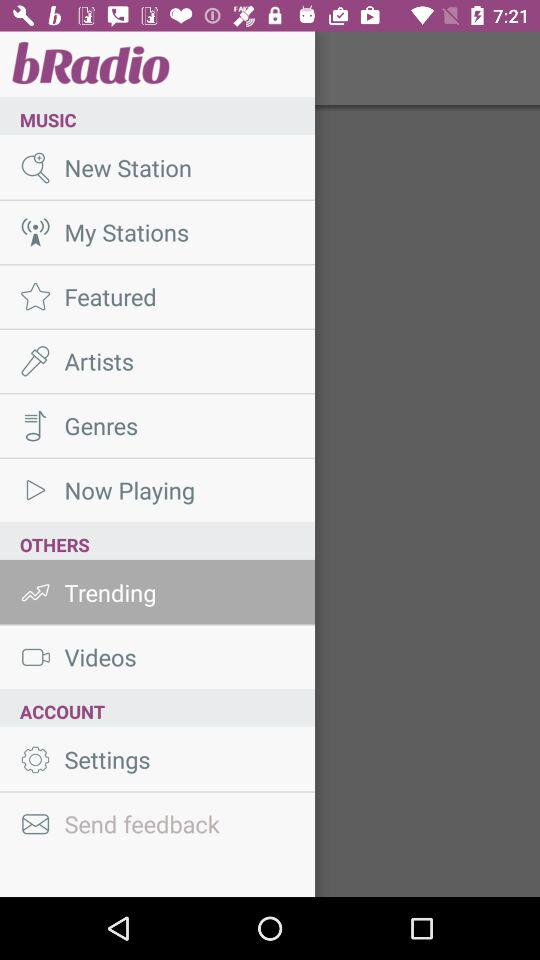What is the name of the application? The name of the application is "bRadio". 